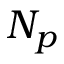Convert formula to latex. <formula><loc_0><loc_0><loc_500><loc_500>N _ { p }</formula> 